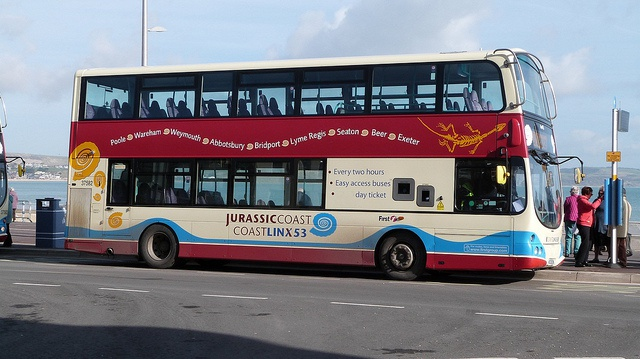Describe the objects in this image and their specific colors. I can see bus in lightblue, black, maroon, brown, and lightgray tones, people in lightblue, black, maroon, and salmon tones, people in lightblue, black, violet, purple, and gray tones, people in lightblue, black, gray, and darkblue tones, and people in lightblue, black, gray, darkgray, and beige tones in this image. 